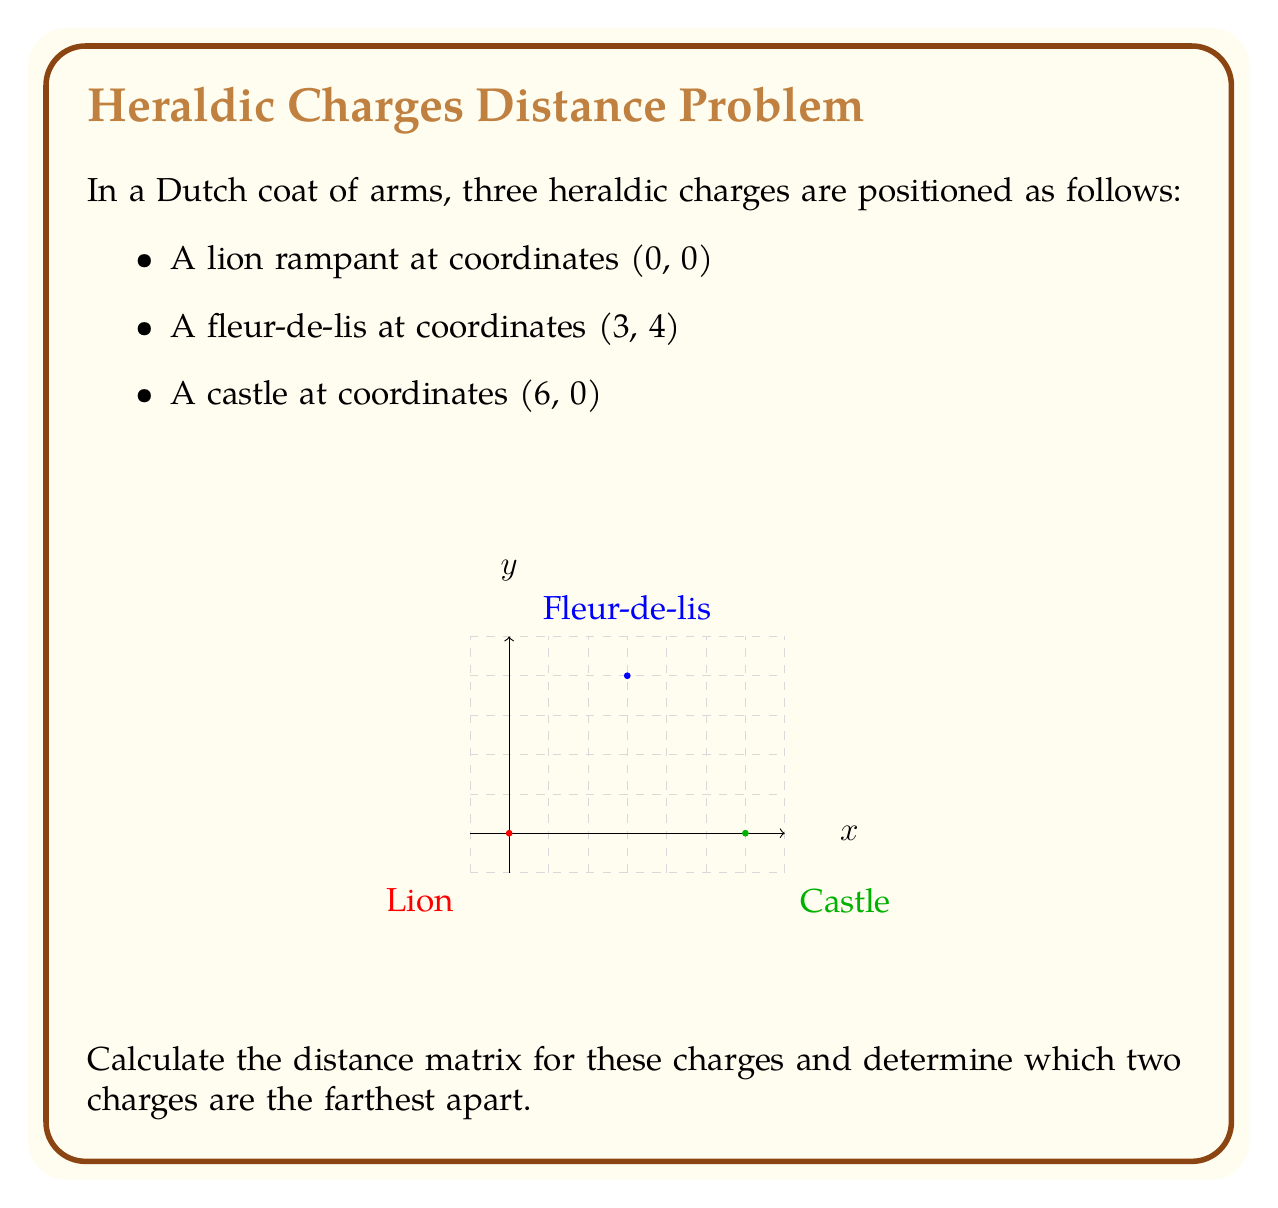Help me with this question. To solve this problem, we need to follow these steps:

1. Calculate the distances between each pair of charges using the distance formula:
   $$d = \sqrt{(x_2-x_1)^2 + (y_2-y_1)^2}$$

2. Construct the distance matrix using these calculated distances.

3. Identify the largest value in the matrix to determine which charges are farthest apart.

Step 1: Calculating distances

a) Lion to Fleur-de-lis:
   $$d_{LF} = \sqrt{(3-0)^2 + (4-0)^2} = \sqrt{9 + 16} = \sqrt{25} = 5$$

b) Lion to Castle:
   $$d_{LC} = \sqrt{(6-0)^2 + (0-0)^2} = \sqrt{36 + 0} = 6$$

c) Fleur-de-lis to Castle:
   $$d_{FC} = \sqrt{(6-3)^2 + (0-4)^2} = \sqrt{9 + 16} = \sqrt{25} = 5$$

Step 2: Constructing the distance matrix

The distance matrix D is:

$$D = \begin{bmatrix}
0 & 5 & 6 \\
5 & 0 & 5 \\
6 & 5 & 0
\end{bmatrix}$$

Where the rows and columns represent Lion, Fleur-de-lis, and Castle in that order.

Step 3: Identifying the largest distance

The largest value in the matrix is 6, which corresponds to the distance between the Lion and the Castle.
Answer: The Lion and the Castle are farthest apart, with a distance of 6 units. 